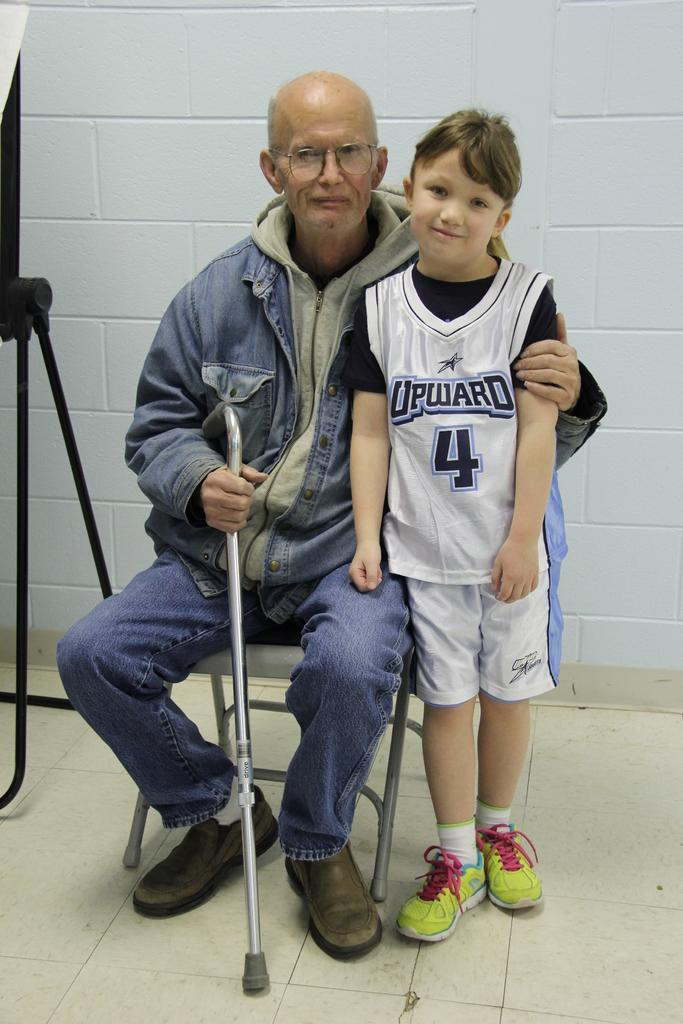<image>
Render a clear and concise summary of the photo. An older man with a cane sits next to a young child wearing an Upward sports jersey. 